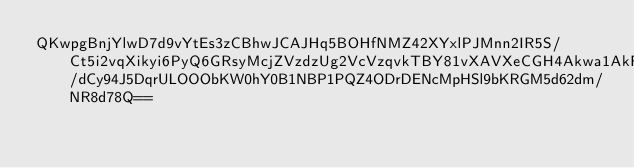<code> <loc_0><loc_0><loc_500><loc_500><_SML_>QKwpgBnjYlwD7d9vYtEs3zCBhwJCAJHq5BOHfNMZ42XYxlPJMnn2IR5S/Ct5i2vqXikyi6PyQ6GRsyMcjZVzdzUg2VcVzqvkTBY81vXAVXeCGH4Akwa1AkFRv69FNonphZgS9yTtlME7Y/dCy94J5DqrULOOObKW0hY0B1NBP1PQZ4ODrDENcMpHSl9bKRGM5d62dm/NR8d78Q==</code> 